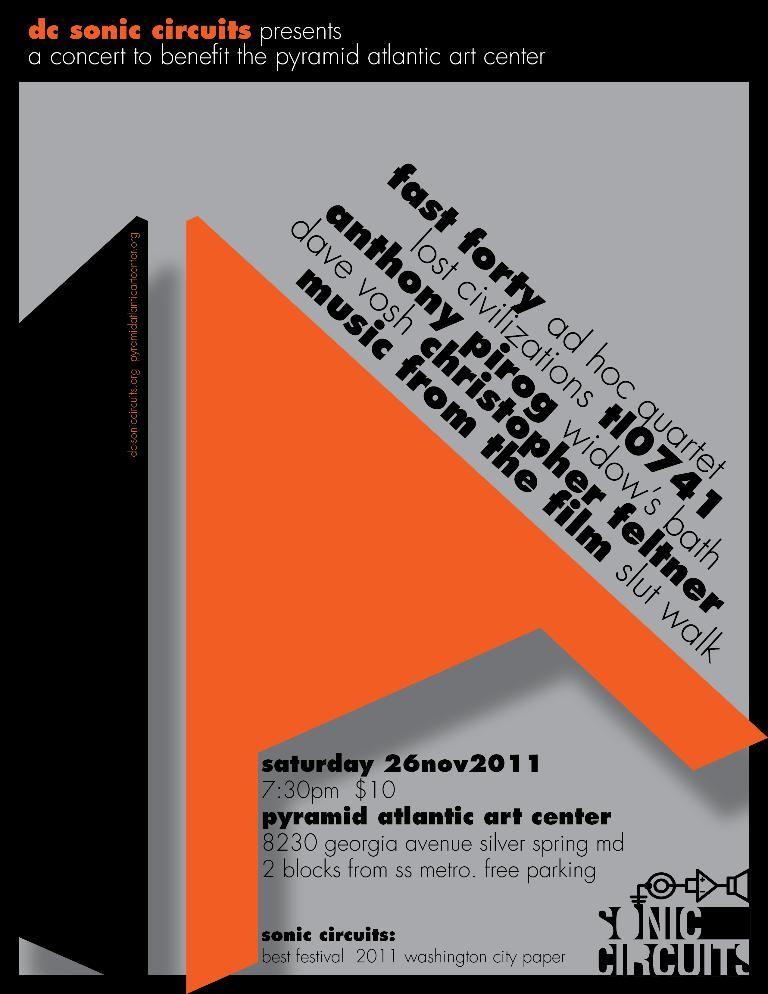<image>
Summarize the visual content of the image. Poster for a concert that takes place at 7:30 for $10. 